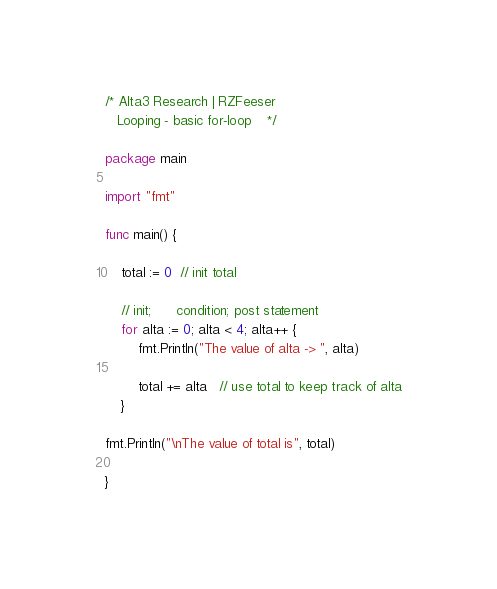Convert code to text. <code><loc_0><loc_0><loc_500><loc_500><_Go_>/* Alta3 Research | RZFeeser
   Looping - basic for-loop    */

package main

import "fmt"

func main() {

    total := 0  // init total
    
    // init;      condition; post statement
    for alta := 0; alta < 4; alta++ {
        fmt.Println("The value of alta -> ", alta)
        
        total += alta   // use total to keep track of alta
    }

fmt.Println("\nThe value of total is", total)
    
}

</code> 